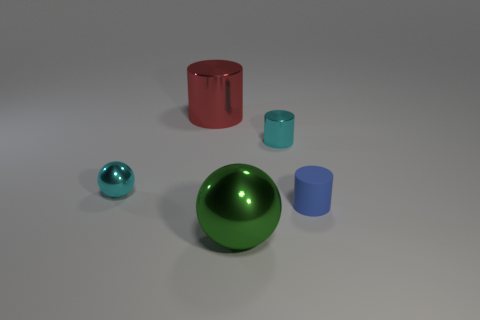Add 5 big gray matte spheres. How many objects exist? 10 Subtract all cylinders. How many objects are left? 2 Add 1 large yellow rubber things. How many large yellow rubber things exist? 1 Subtract 0 purple cubes. How many objects are left? 5 Subtract all big yellow metal blocks. Subtract all cylinders. How many objects are left? 2 Add 1 large metal cylinders. How many large metal cylinders are left? 2 